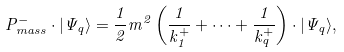<formula> <loc_0><loc_0><loc_500><loc_500>P _ { m a s s } ^ { - } \cdot | \Psi _ { q } \rangle = \frac { 1 } { 2 } m ^ { 2 } \left ( \frac { 1 } { k _ { 1 } ^ { + } } + \cdots + \frac { 1 } { k _ { q } ^ { + } } \right ) \cdot | \Psi _ { q } \rangle ,</formula> 